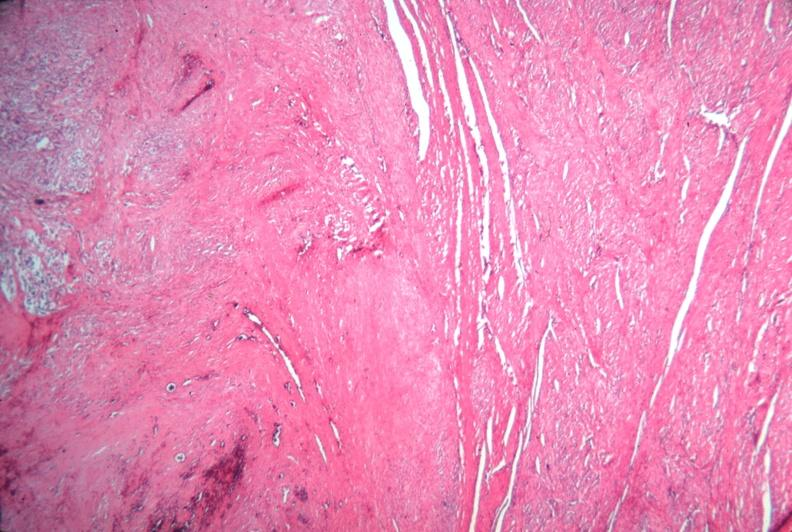does this image show uterus, leiomyoma?
Answer the question using a single word or phrase. Yes 